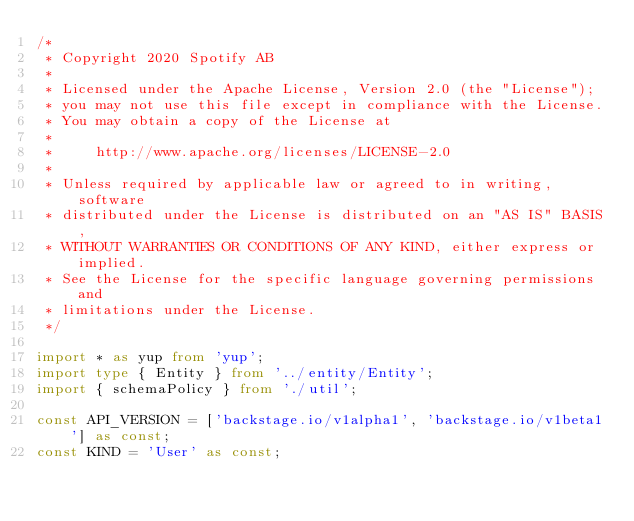Convert code to text. <code><loc_0><loc_0><loc_500><loc_500><_TypeScript_>/*
 * Copyright 2020 Spotify AB
 *
 * Licensed under the Apache License, Version 2.0 (the "License");
 * you may not use this file except in compliance with the License.
 * You may obtain a copy of the License at
 *
 *     http://www.apache.org/licenses/LICENSE-2.0
 *
 * Unless required by applicable law or agreed to in writing, software
 * distributed under the License is distributed on an "AS IS" BASIS,
 * WITHOUT WARRANTIES OR CONDITIONS OF ANY KIND, either express or implied.
 * See the License for the specific language governing permissions and
 * limitations under the License.
 */

import * as yup from 'yup';
import type { Entity } from '../entity/Entity';
import { schemaPolicy } from './util';

const API_VERSION = ['backstage.io/v1alpha1', 'backstage.io/v1beta1'] as const;
const KIND = 'User' as const;
</code> 